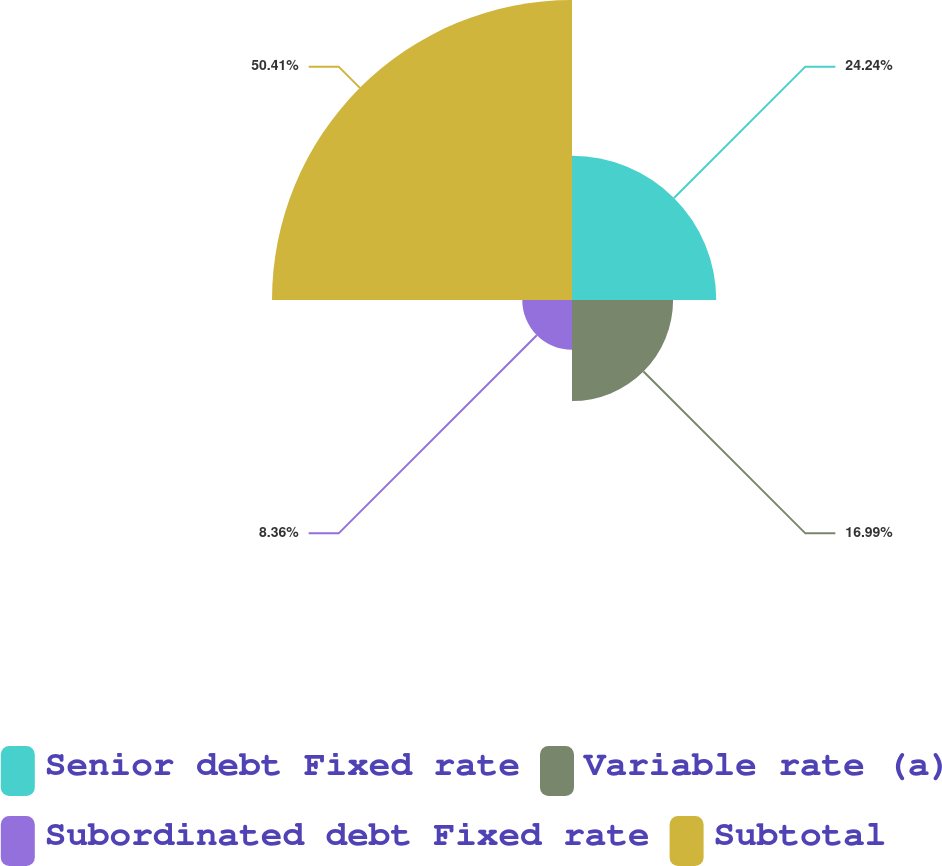Convert chart to OTSL. <chart><loc_0><loc_0><loc_500><loc_500><pie_chart><fcel>Senior debt Fixed rate<fcel>Variable rate (a)<fcel>Subordinated debt Fixed rate<fcel>Subtotal<nl><fcel>24.24%<fcel>16.99%<fcel>8.36%<fcel>50.42%<nl></chart> 